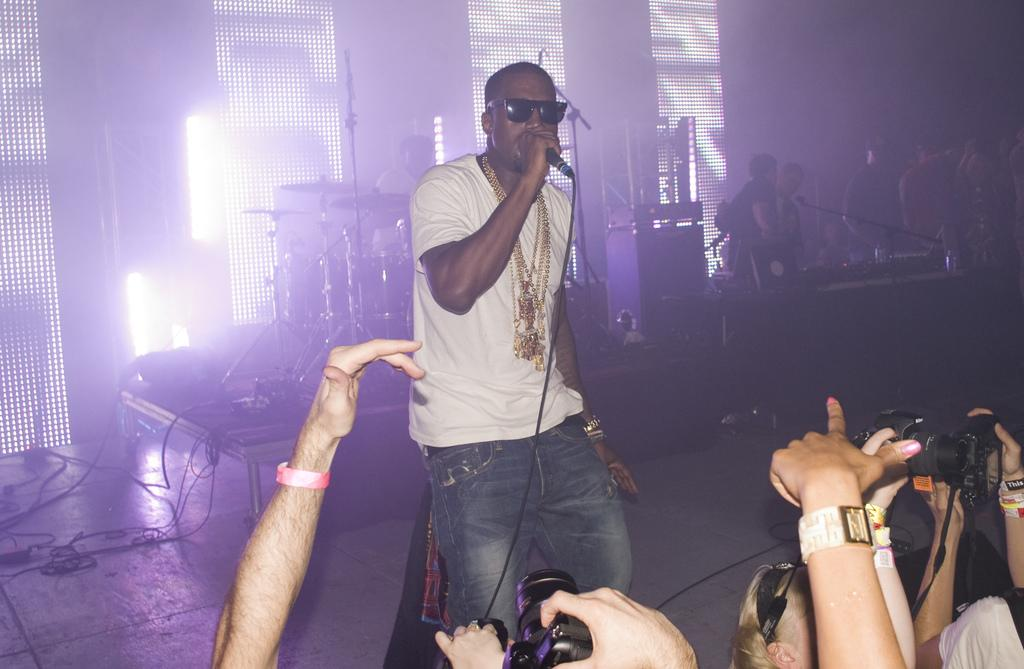What can be seen in the image? There are people in the image. What is the man holding in the image? The man is holding a mic in the image. What is the man doing with the mic? The man is singing a song while holding the mic. What type of church can be seen in the background of the image? There is no church present in the image; it only shows people and a man holding a mic. 